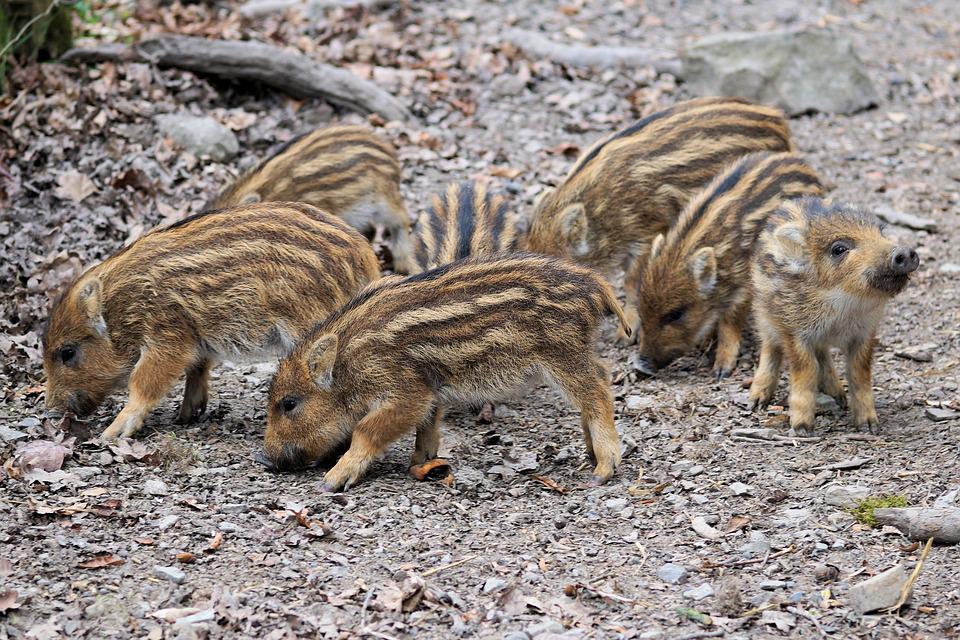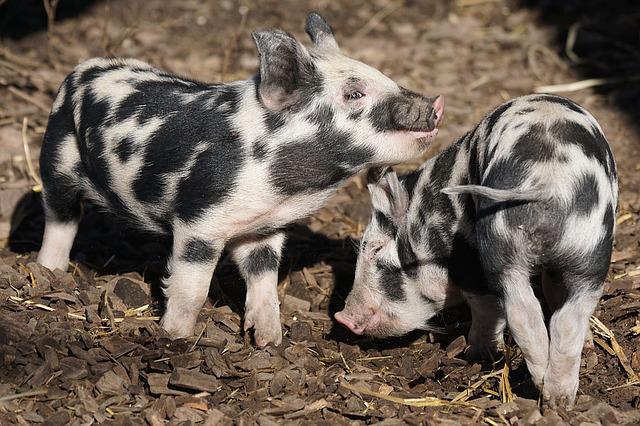The first image is the image on the left, the second image is the image on the right. Analyze the images presented: Is the assertion "An image includes at least one tusked boar lying on the ground, and at least one other kind of mammal in the picture." valid? Answer yes or no. No. The first image is the image on the left, the second image is the image on the right. For the images shown, is this caption "The right image contains exactly two pigs." true? Answer yes or no. Yes. 